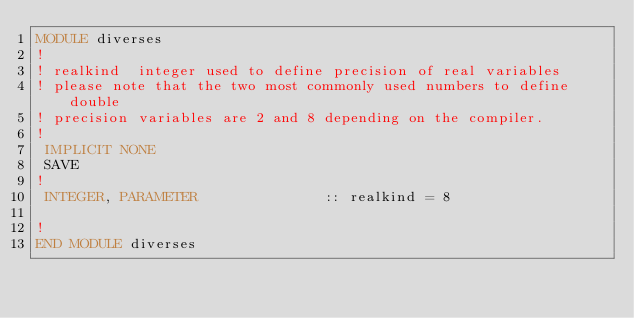Convert code to text. <code><loc_0><loc_0><loc_500><loc_500><_FORTRAN_>MODULE diverses
!
! realkind	integer used to define precision of real variables
! please note that the two most commonly used numbers to define double
! precision variables are 2 and 8 depending on the compiler.
!
 IMPLICIT NONE
 SAVE
!
 INTEGER, PARAMETER               :: realkind = 8

!
END MODULE diverses
</code> 